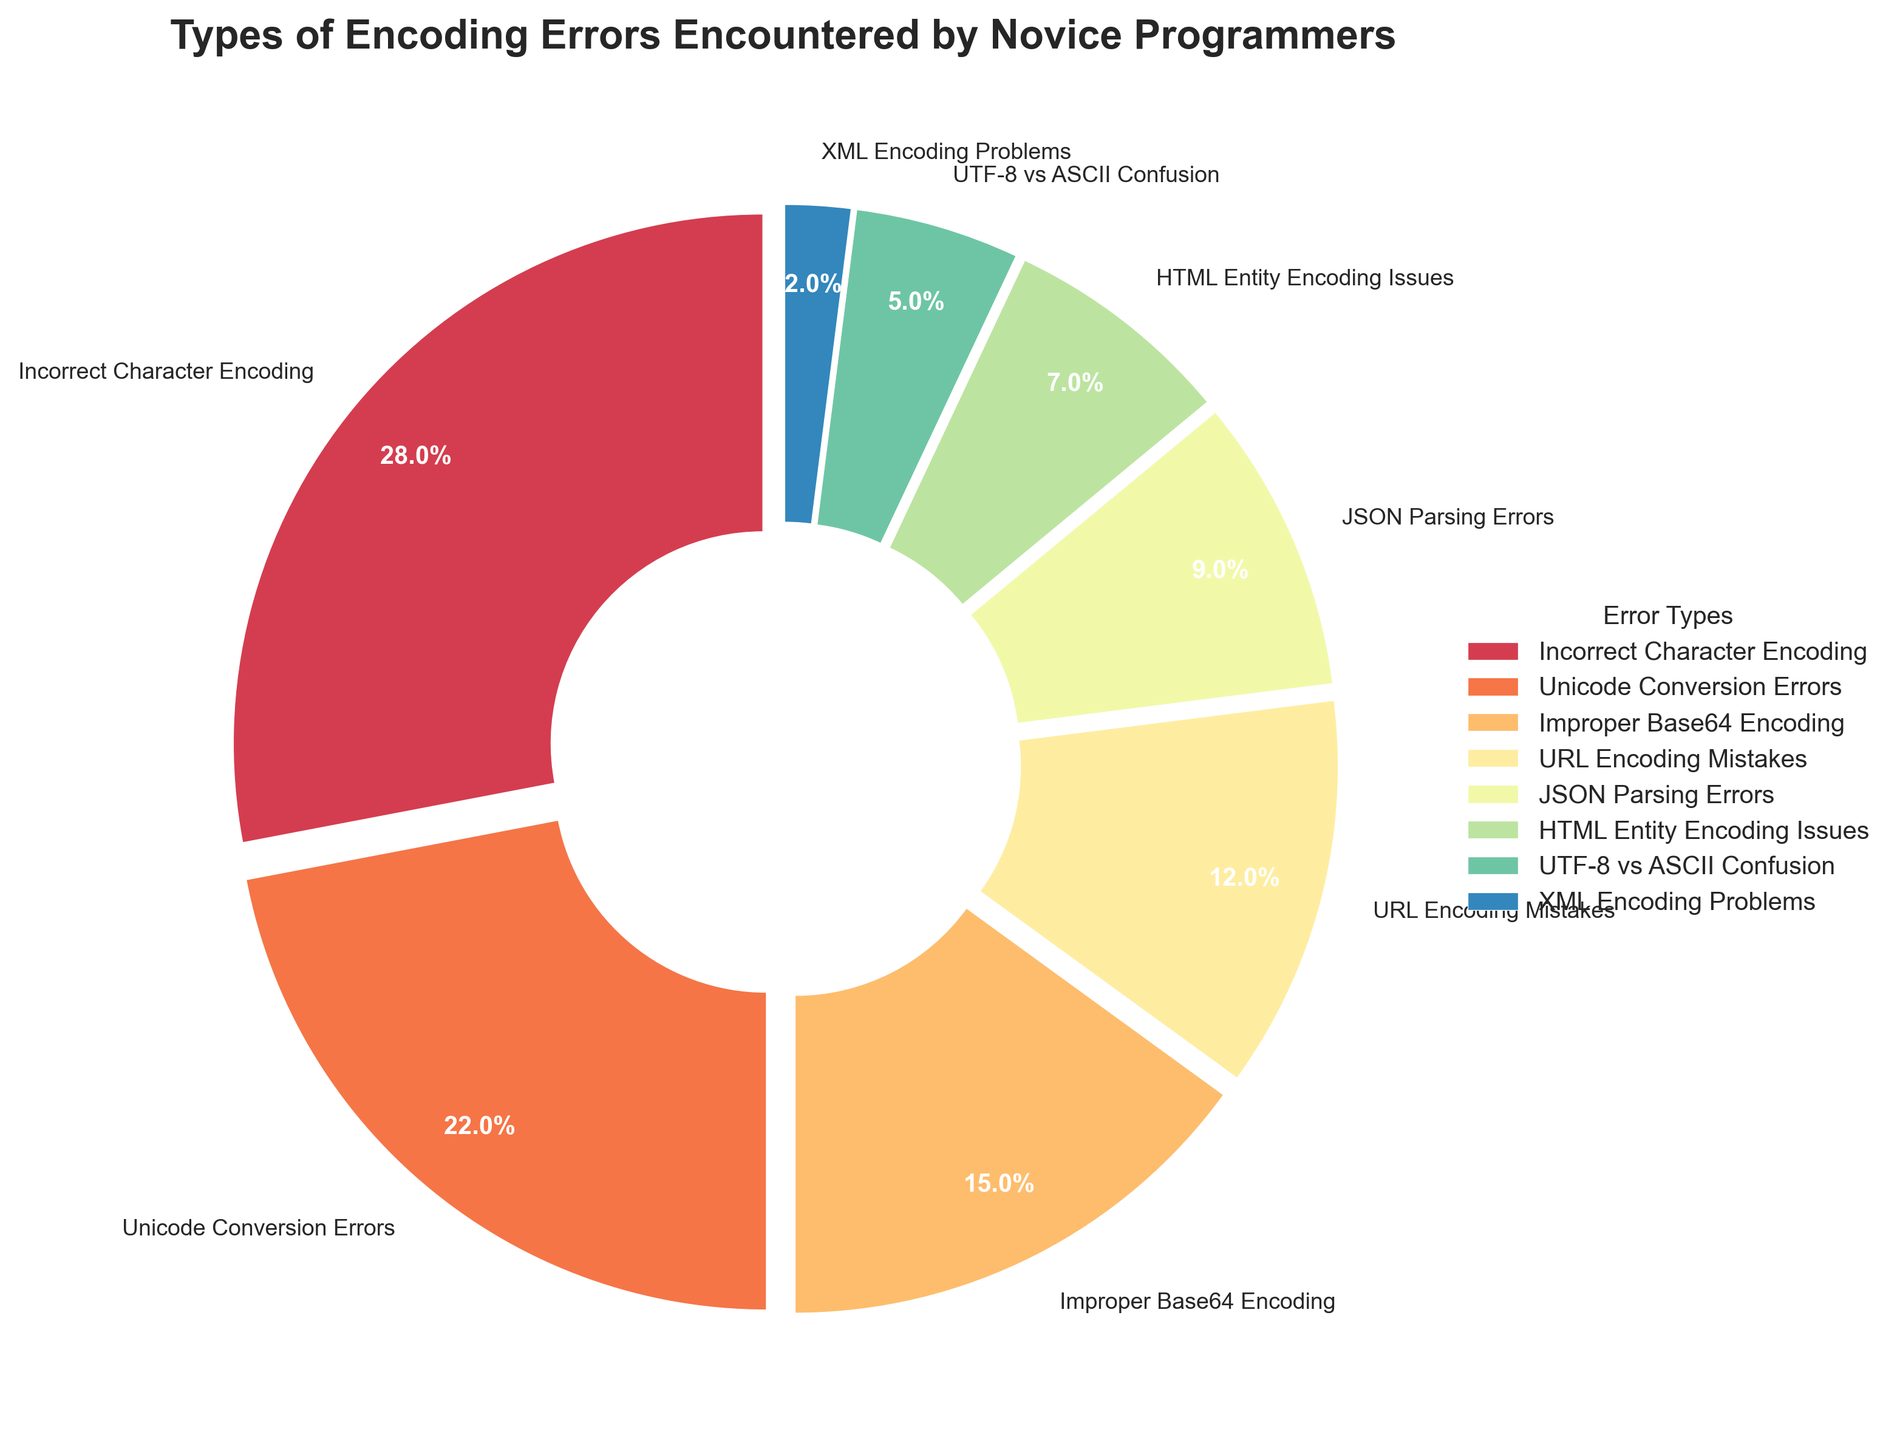What percentage of encoding errors are due to Incorrect Character Encoding, Unicode Conversion Errors, and Improper Base64 Encoding combined? The percentages are listed directly on the chart: Incorrect Character Encoding (28%), Unicode Conversion Errors (22%), and Improper Base64 Encoding (15%). Add these percentages together: \( 28 + 22 + 15 = 65 \)
Answer: 65% What is the most common type of encoding error encountered by novice programmers? The chart shows that Incorrect Character Encoding has the largest wedge, indicating the highest percentage of 28%.
Answer: Incorrect Character Encoding Which types of encoding errors combined contribute less than 10%? The chart segments that contribute less than 10% are XML Encoding Problems (2%) and UTF-8 vs ASCII Confusion (5%). Sum these percentages: \( 2 + 5 = 7 \)
Answer: XML Encoding Problems and UTF-8 vs ASCII Confusion How much larger is the percentage of Incorrect Character Encoding errors compared to HTML Entity Encoding Issues? Incorrect Character Encoding errors account for 28%, while HTML Entity Encoding Issues account for 7%. Calculate the difference: \( 28 - 7 = 21 \)
Answer: 21% Which type of encoding error is visually represented by the smallest wedge and what is its percentage? The smallest wedge is visually the XML Encoding Problems with a percentage of 2%.
Answer: XML Encoding Problems, 2% What percentage of the encoding errors are related to URL Encoding Mistakes and JSON Parsing Errors combined? URL Encoding Mistakes (12%) and JSON Parsing Errors (9%) are shown on the chart. Their combined percentage is: \( 12 + 9 = 21 \)
Answer: 21% Does Unicode Conversion Errors account for a higher percentage of errors than all improper encoding errors combined (Base64, URL, HTML Entity)? Unicode Conversion Errors account for 22%. The combined percentage of Improper Base64 Encoding (15%), URL Encoding Mistakes (12%), and HTML Entity Encoding Issues (7%) is \( 15 + 12 + 7 = 34 \). Thus, 22% is less than 34%.
Answer: No Which types of errors make up less than 20% individually and what are their percentages? The types of errors that each make up less than 20% are: Improper Base64 Encoding (15%), URL Encoding Mistakes (12%), JSON Parsing Errors (9%), HTML Entity Encoding Issues (7%), UTF-8 vs ASCII Confusion (5%), and XML Encoding Problems (2%).
Answer: Improper Base64 Encoding (15%), URL Encoding Mistakes (12%), JSON Parsing Errors (9%), HTML Entity Encoding Issues (7%), UTF-8 vs ASCII Confusion (5%), XML Encoding Problems (2%) What is the difference in percentage between the most common and the least common error types? The most common error is Incorrect Character Encoding (28%), and the least common is XML Encoding Problems (2%). The difference between them is \( 28 - 2 = 26 \).
Answer: 26% Is the sum of Improper Base64 Encoding and HTML Entity Encoding Issues equal to the percentage of Unicode Conversion Errors? Improper Base64 Encoding is 15% and HTML Entity Encoding Issues is 7%. Their sum is \( 15 + 7 = 22 \). Unicode Conversion Errors is also 22%. Therefore, they are equal.
Answer: Yes 